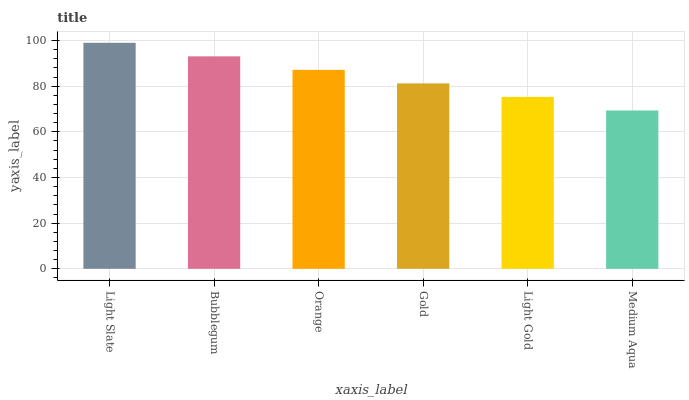Is Bubblegum the minimum?
Answer yes or no. No. Is Bubblegum the maximum?
Answer yes or no. No. Is Light Slate greater than Bubblegum?
Answer yes or no. Yes. Is Bubblegum less than Light Slate?
Answer yes or no. Yes. Is Bubblegum greater than Light Slate?
Answer yes or no. No. Is Light Slate less than Bubblegum?
Answer yes or no. No. Is Orange the high median?
Answer yes or no. Yes. Is Gold the low median?
Answer yes or no. Yes. Is Medium Aqua the high median?
Answer yes or no. No. Is Orange the low median?
Answer yes or no. No. 